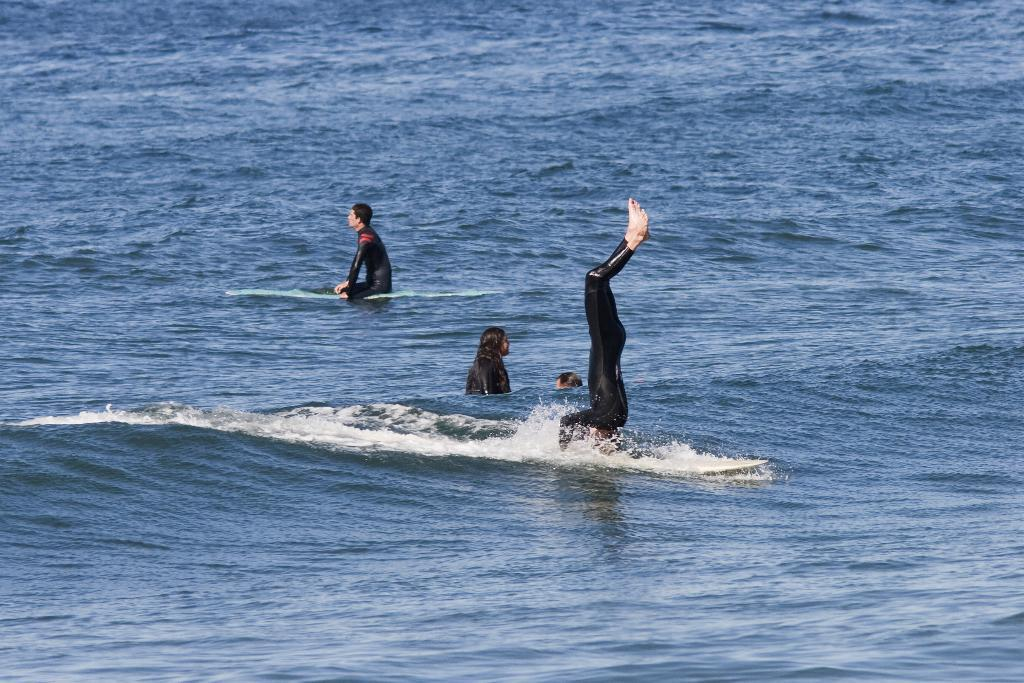How many people are in the image? There are people in the image, but the exact number cannot be determined from the provided facts. What is the primary element visible in the image? There is water visible in the image. Can you tell me how many basketballs are floating in the water in the image? There is no mention of basketballs in the image, so it cannot be determined if any are present or floating in the water. 